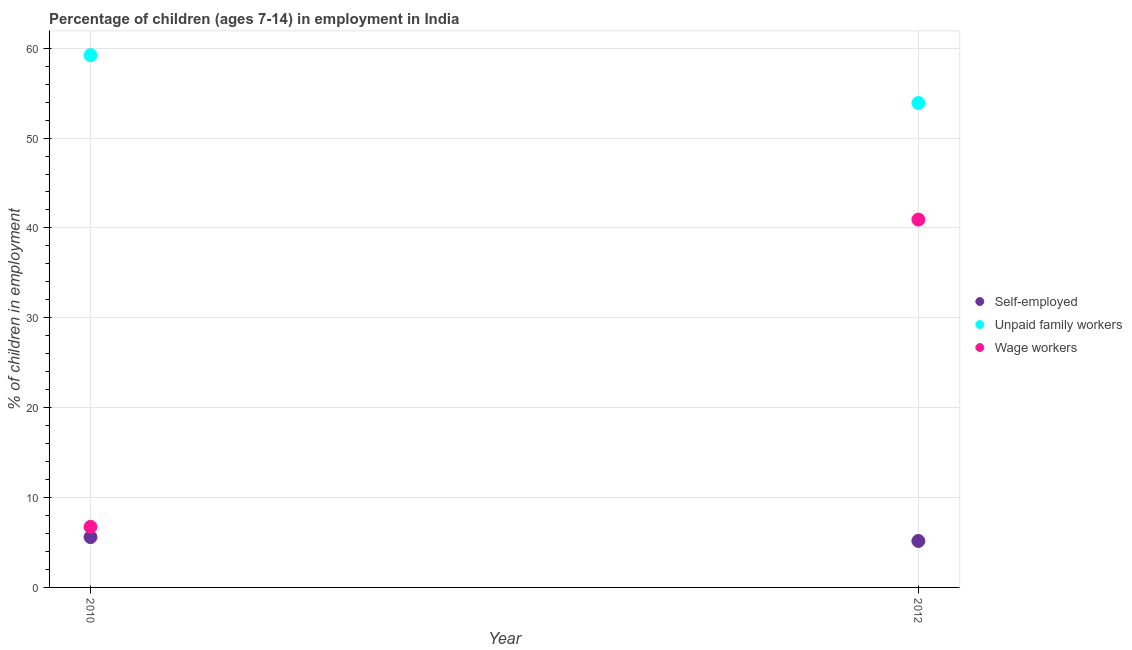How many different coloured dotlines are there?
Keep it short and to the point. 3. Across all years, what is the maximum percentage of self employed children?
Ensure brevity in your answer.  5.6. Across all years, what is the minimum percentage of children employed as wage workers?
Provide a succinct answer. 6.74. In which year was the percentage of children employed as unpaid family workers minimum?
Offer a terse response. 2012. What is the total percentage of self employed children in the graph?
Provide a short and direct response. 10.77. What is the difference between the percentage of children employed as wage workers in 2010 and that in 2012?
Provide a short and direct response. -34.19. What is the difference between the percentage of children employed as wage workers in 2010 and the percentage of children employed as unpaid family workers in 2012?
Provide a succinct answer. -47.16. What is the average percentage of self employed children per year?
Your answer should be very brief. 5.38. In the year 2012, what is the difference between the percentage of children employed as wage workers and percentage of children employed as unpaid family workers?
Your answer should be very brief. -12.97. In how many years, is the percentage of children employed as unpaid family workers greater than 16 %?
Offer a terse response. 2. What is the ratio of the percentage of children employed as wage workers in 2010 to that in 2012?
Make the answer very short. 0.16. Is the percentage of children employed as unpaid family workers in 2010 less than that in 2012?
Offer a very short reply. No. In how many years, is the percentage of self employed children greater than the average percentage of self employed children taken over all years?
Keep it short and to the point. 1. Is the percentage of self employed children strictly less than the percentage of children employed as unpaid family workers over the years?
Provide a succinct answer. Yes. Are the values on the major ticks of Y-axis written in scientific E-notation?
Give a very brief answer. No. Where does the legend appear in the graph?
Offer a terse response. Center right. How many legend labels are there?
Give a very brief answer. 3. How are the legend labels stacked?
Make the answer very short. Vertical. What is the title of the graph?
Offer a very short reply. Percentage of children (ages 7-14) in employment in India. What is the label or title of the Y-axis?
Your answer should be compact. % of children in employment. What is the % of children in employment of Unpaid family workers in 2010?
Ensure brevity in your answer.  59.23. What is the % of children in employment of Wage workers in 2010?
Keep it short and to the point. 6.74. What is the % of children in employment of Self-employed in 2012?
Provide a succinct answer. 5.17. What is the % of children in employment of Unpaid family workers in 2012?
Your response must be concise. 53.9. What is the % of children in employment of Wage workers in 2012?
Your answer should be compact. 40.93. Across all years, what is the maximum % of children in employment of Unpaid family workers?
Offer a very short reply. 59.23. Across all years, what is the maximum % of children in employment of Wage workers?
Provide a succinct answer. 40.93. Across all years, what is the minimum % of children in employment in Self-employed?
Your answer should be very brief. 5.17. Across all years, what is the minimum % of children in employment in Unpaid family workers?
Offer a very short reply. 53.9. Across all years, what is the minimum % of children in employment in Wage workers?
Make the answer very short. 6.74. What is the total % of children in employment in Self-employed in the graph?
Offer a very short reply. 10.77. What is the total % of children in employment of Unpaid family workers in the graph?
Provide a short and direct response. 113.13. What is the total % of children in employment in Wage workers in the graph?
Offer a terse response. 47.67. What is the difference between the % of children in employment in Self-employed in 2010 and that in 2012?
Your answer should be very brief. 0.43. What is the difference between the % of children in employment in Unpaid family workers in 2010 and that in 2012?
Offer a terse response. 5.33. What is the difference between the % of children in employment in Wage workers in 2010 and that in 2012?
Make the answer very short. -34.19. What is the difference between the % of children in employment of Self-employed in 2010 and the % of children in employment of Unpaid family workers in 2012?
Make the answer very short. -48.3. What is the difference between the % of children in employment of Self-employed in 2010 and the % of children in employment of Wage workers in 2012?
Provide a succinct answer. -35.33. What is the difference between the % of children in employment in Unpaid family workers in 2010 and the % of children in employment in Wage workers in 2012?
Give a very brief answer. 18.3. What is the average % of children in employment of Self-employed per year?
Ensure brevity in your answer.  5.38. What is the average % of children in employment in Unpaid family workers per year?
Your answer should be very brief. 56.56. What is the average % of children in employment of Wage workers per year?
Provide a succinct answer. 23.84. In the year 2010, what is the difference between the % of children in employment in Self-employed and % of children in employment in Unpaid family workers?
Keep it short and to the point. -53.63. In the year 2010, what is the difference between the % of children in employment of Self-employed and % of children in employment of Wage workers?
Your response must be concise. -1.14. In the year 2010, what is the difference between the % of children in employment of Unpaid family workers and % of children in employment of Wage workers?
Keep it short and to the point. 52.49. In the year 2012, what is the difference between the % of children in employment in Self-employed and % of children in employment in Unpaid family workers?
Your response must be concise. -48.73. In the year 2012, what is the difference between the % of children in employment in Self-employed and % of children in employment in Wage workers?
Your response must be concise. -35.76. In the year 2012, what is the difference between the % of children in employment in Unpaid family workers and % of children in employment in Wage workers?
Keep it short and to the point. 12.97. What is the ratio of the % of children in employment of Self-employed in 2010 to that in 2012?
Make the answer very short. 1.08. What is the ratio of the % of children in employment in Unpaid family workers in 2010 to that in 2012?
Your response must be concise. 1.1. What is the ratio of the % of children in employment of Wage workers in 2010 to that in 2012?
Offer a very short reply. 0.16. What is the difference between the highest and the second highest % of children in employment in Self-employed?
Provide a succinct answer. 0.43. What is the difference between the highest and the second highest % of children in employment in Unpaid family workers?
Make the answer very short. 5.33. What is the difference between the highest and the second highest % of children in employment of Wage workers?
Provide a succinct answer. 34.19. What is the difference between the highest and the lowest % of children in employment in Self-employed?
Provide a succinct answer. 0.43. What is the difference between the highest and the lowest % of children in employment in Unpaid family workers?
Provide a short and direct response. 5.33. What is the difference between the highest and the lowest % of children in employment in Wage workers?
Give a very brief answer. 34.19. 